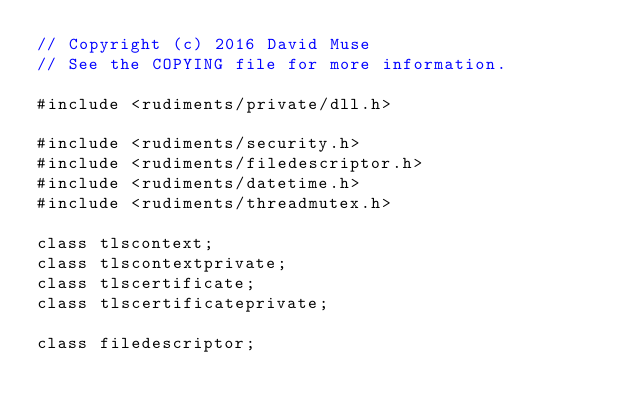<code> <loc_0><loc_0><loc_500><loc_500><_C_>// Copyright (c) 2016 David Muse
// See the COPYING file for more information.

#include <rudiments/private/dll.h>

#include <rudiments/security.h>
#include <rudiments/filedescriptor.h>
#include <rudiments/datetime.h>
#include <rudiments/threadmutex.h>

class tlscontext;
class tlscontextprivate;
class tlscertificate;
class tlscertificateprivate;

class filedescriptor;
</code> 